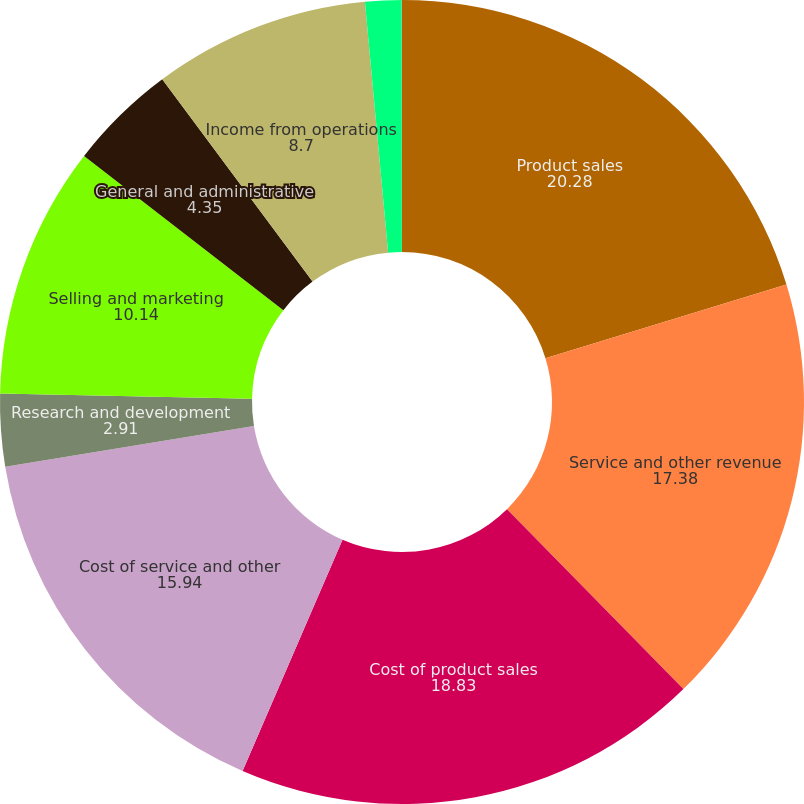Convert chart to OTSL. <chart><loc_0><loc_0><loc_500><loc_500><pie_chart><fcel>Product sales<fcel>Service and other revenue<fcel>Cost of product sales<fcel>Cost of service and other<fcel>Research and development<fcel>Selling and marketing<fcel>General and administrative<fcel>Income from operations<fcel>Interest income<fcel>Interest and other income<nl><fcel>20.28%<fcel>17.38%<fcel>18.83%<fcel>15.94%<fcel>2.91%<fcel>10.14%<fcel>4.35%<fcel>8.7%<fcel>1.46%<fcel>0.01%<nl></chart> 